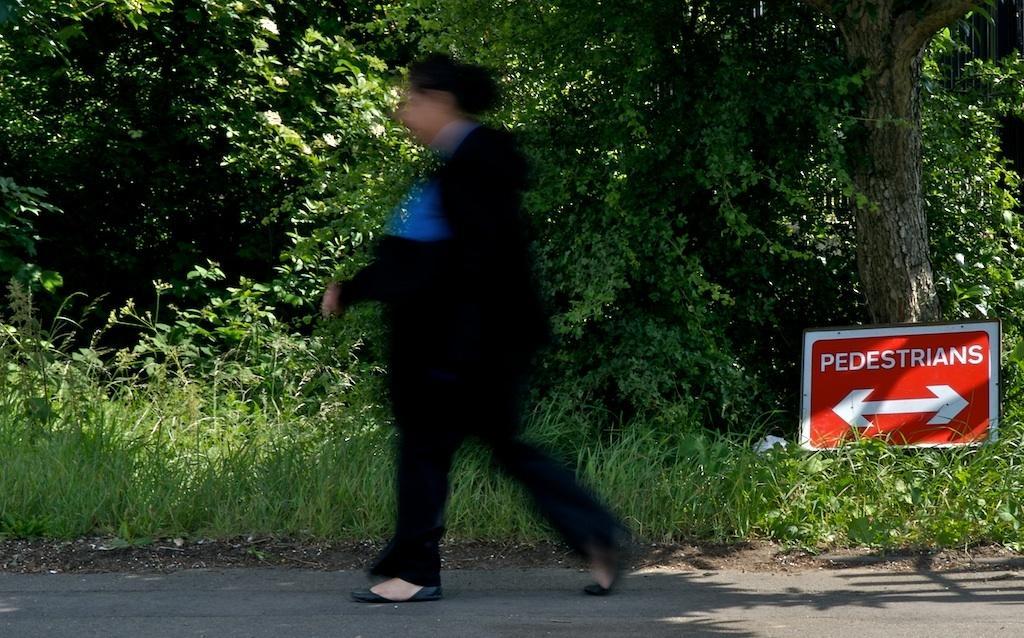Could you give a brief overview of what you see in this image? In the center of the image, we can see a person walking on the road and in the background, there are trees and we can see a board. 